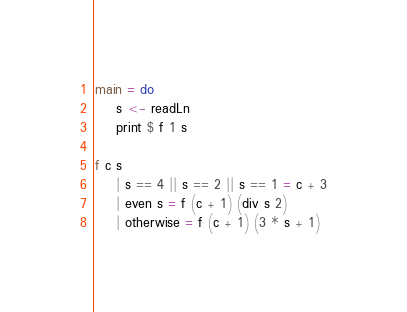<code> <loc_0><loc_0><loc_500><loc_500><_Haskell_>main = do
    s <- readLn
    print $ f 1 s

f c s
    | s == 4 || s == 2 || s == 1 = c + 3
    | even s = f (c + 1) (div s 2)
    | otherwise = f (c + 1) (3 * s + 1)</code> 